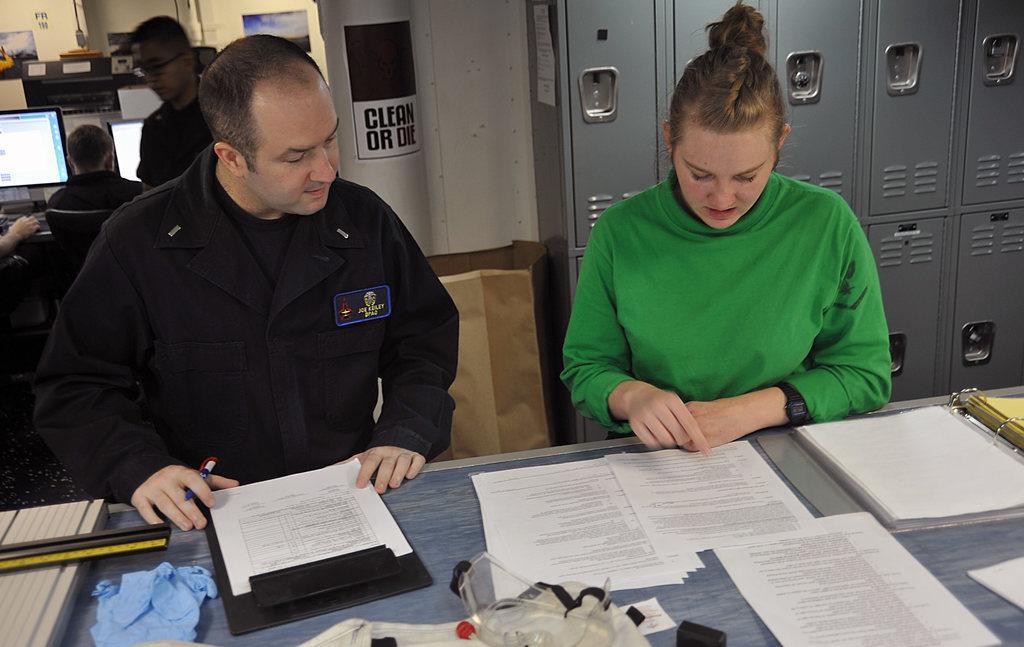Could you give a brief overview of what you see in this image? In this image we can see people. At the bottom there is a table and there are papers, filed, scale, pen and some objects placed on the table. In the background there are lockers and we can see systems. There are boards. 